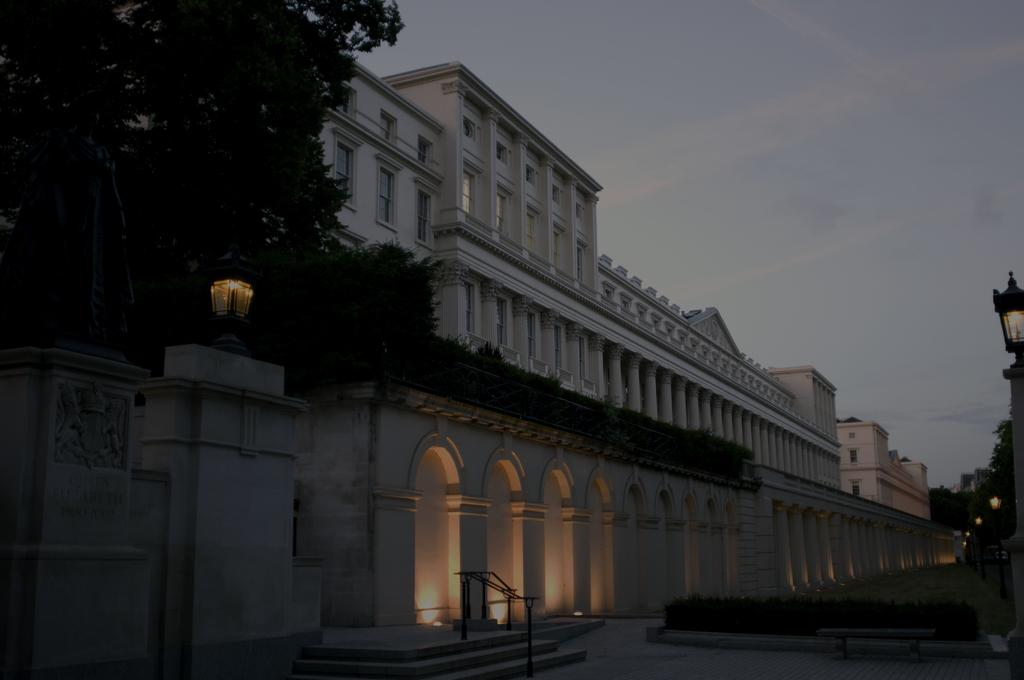What type of structure is in the image? There is a building in the image. What other natural elements can be seen in the image? There are trees in the image. Is there any entrance or barrier visible in the image? Yes, there is a gate in the image. What can be used to illuminate the area in the image? Lights are present in the image, and light poles are visible. What is visible in the background of the image? The sky is visible in the background of the image. What type of invention is being measured by the tent in the image? There is no tent or invention present in the image. 